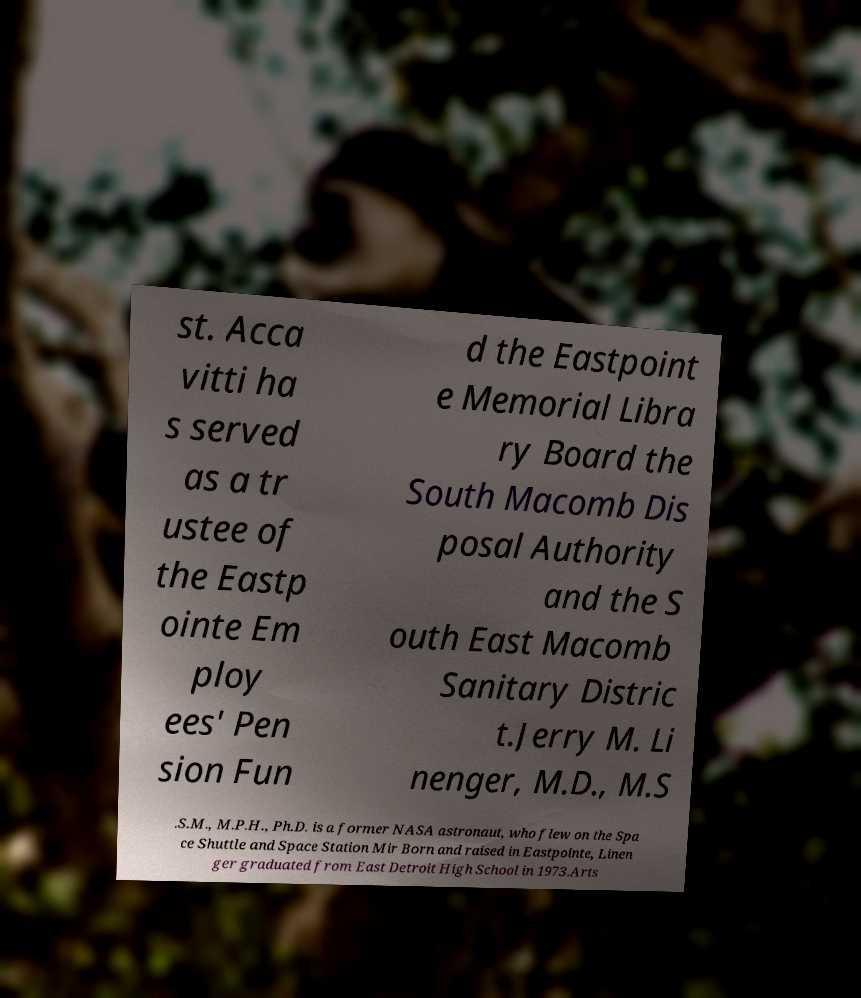Could you assist in decoding the text presented in this image and type it out clearly? st. Acca vitti ha s served as a tr ustee of the Eastp ointe Em ploy ees' Pen sion Fun d the Eastpoint e Memorial Libra ry Board the South Macomb Dis posal Authority and the S outh East Macomb Sanitary Distric t.Jerry M. Li nenger, M.D., M.S .S.M., M.P.H., Ph.D. is a former NASA astronaut, who flew on the Spa ce Shuttle and Space Station Mir Born and raised in Eastpointe, Linen ger graduated from East Detroit High School in 1973.Arts 